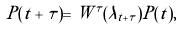Convert formula to latex. <formula><loc_0><loc_0><loc_500><loc_500>P ( t + \tau ) = W ^ { \tau } ( \lambda _ { t + \tau } ) P ( t ) ,</formula> 